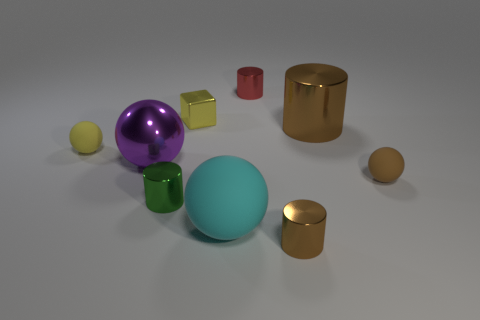Can you describe the lighting in the image? The objects in the image are illuminated by a soft, diffused light source that seems to come from above, casting gentle shadows beneath the objects. The lighting does not create harsh highlights but instead emphasizes the colors and textures of the materials. This type of lighting suggests an indoor setting, possibly a studio, where the conditions are controlled to avoid harsh reflections and shadows. 